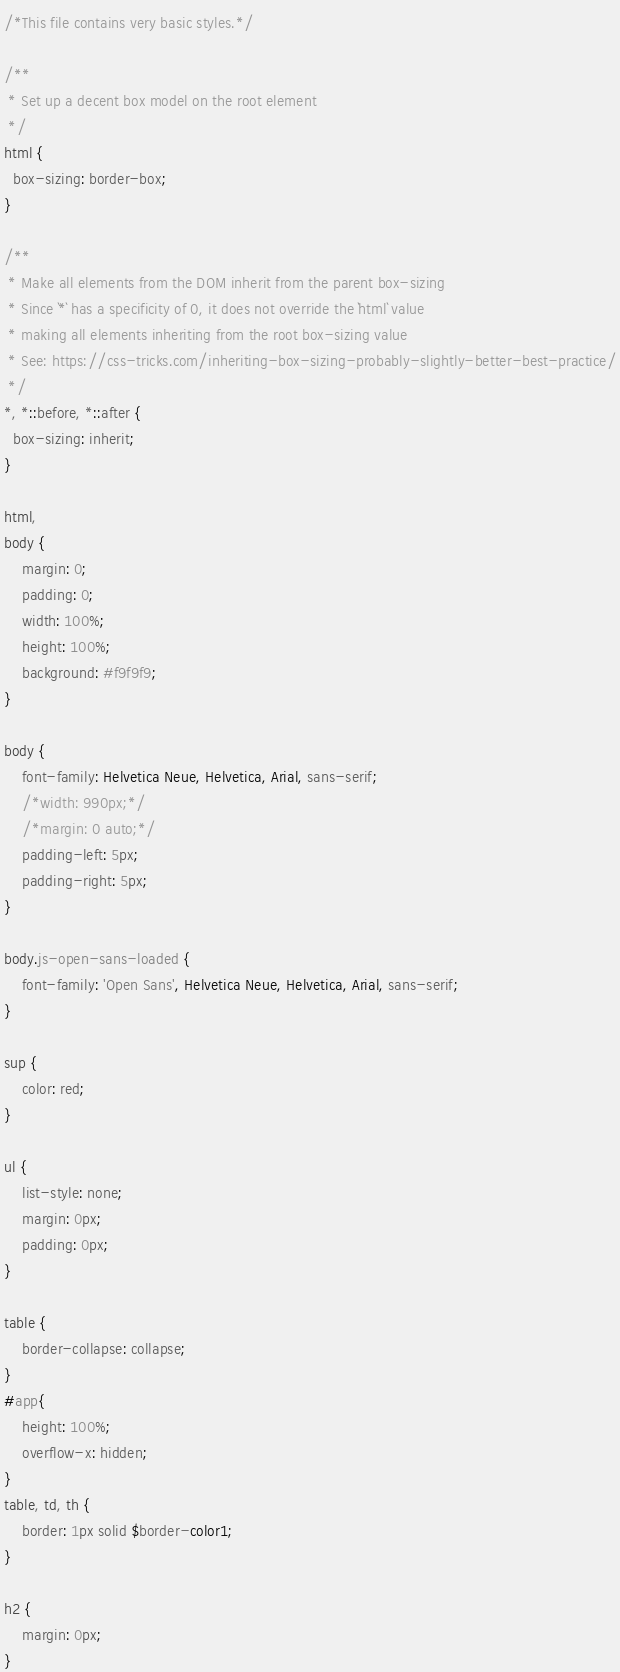Convert code to text. <code><loc_0><loc_0><loc_500><loc_500><_CSS_>/*This file contains very basic styles.*/

/**
 * Set up a decent box model on the root element
 */
html {
  box-sizing: border-box;
}

/**
 * Make all elements from the DOM inherit from the parent box-sizing
 * Since `*` has a specificity of 0, it does not override the `html` value
 * making all elements inheriting from the root box-sizing value
 * See: https://css-tricks.com/inheriting-box-sizing-probably-slightly-better-best-practice/
 */
*, *::before, *::after {
  box-sizing: inherit;
}

html,
body {
    margin: 0;
    padding: 0;
    width: 100%;
    height: 100%;
    background: #f9f9f9;
}

body {
    font-family: Helvetica Neue, Helvetica, Arial, sans-serif;
    /*width: 990px;*/
    /*margin: 0 auto;*/
    padding-left: 5px;
    padding-right: 5px;
}

body.js-open-sans-loaded {
	font-family: 'Open Sans', Helvetica Neue, Helvetica, Arial, sans-serif;
}

sup {
    color: red;
}

ul {
    list-style: none;
    margin: 0px;
    padding: 0px;
}

table {
    border-collapse: collapse;
}
#app{
    height: 100%;
    overflow-x: hidden;
}
table, td, th {
    border: 1px solid $border-color1;
}

h2 {
    margin: 0px;
}</code> 